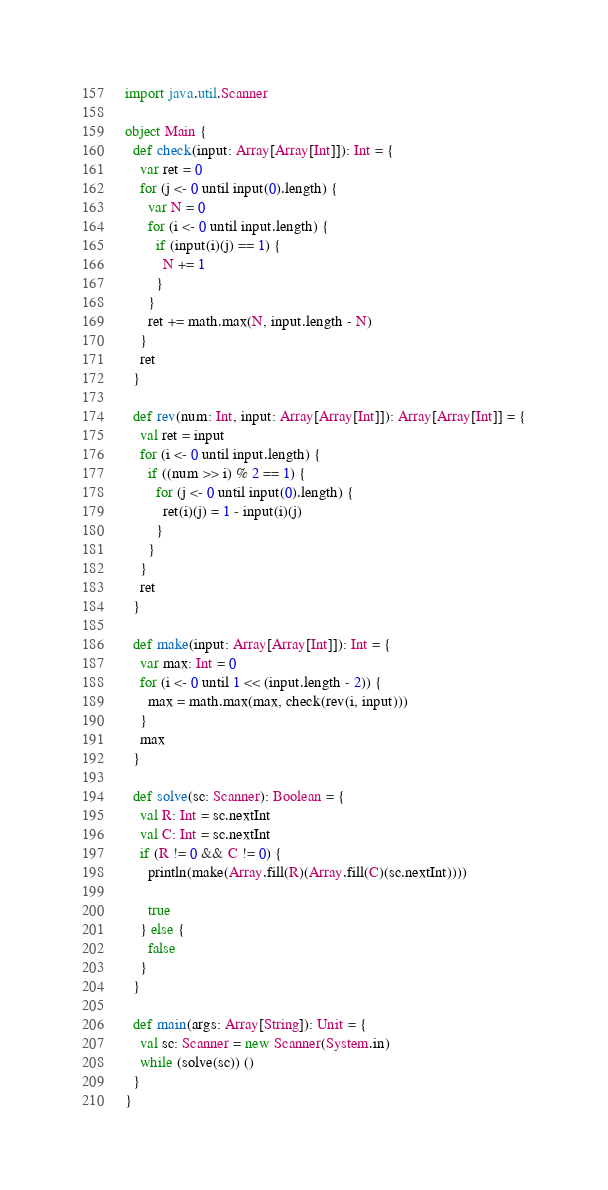Convert code to text. <code><loc_0><loc_0><loc_500><loc_500><_Scala_>import java.util.Scanner

object Main {
  def check(input: Array[Array[Int]]): Int = {
    var ret = 0
    for (j <- 0 until input(0).length) {
      var N = 0
      for (i <- 0 until input.length) {
        if (input(i)(j) == 1) {
          N += 1
        }
      }
      ret += math.max(N, input.length - N)
    }
    ret
  }

  def rev(num: Int, input: Array[Array[Int]]): Array[Array[Int]] = {
    val ret = input
    for (i <- 0 until input.length) {
      if ((num >> i) % 2 == 1) {
        for (j <- 0 until input(0).length) {
          ret(i)(j) = 1 - input(i)(j)
        }
      }
    }
    ret
  }

  def make(input: Array[Array[Int]]): Int = {
    var max: Int = 0
    for (i <- 0 until 1 << (input.length - 2)) {
      max = math.max(max, check(rev(i, input)))
    }
    max
  }

  def solve(sc: Scanner): Boolean = {
    val R: Int = sc.nextInt
    val C: Int = sc.nextInt
    if (R != 0 && C != 0) {
      println(make(Array.fill(R)(Array.fill(C)(sc.nextInt))))

      true
    } else {
      false
    }
  }

  def main(args: Array[String]): Unit = {
    val sc: Scanner = new Scanner(System.in)
    while (solve(sc)) ()
  }
}</code> 